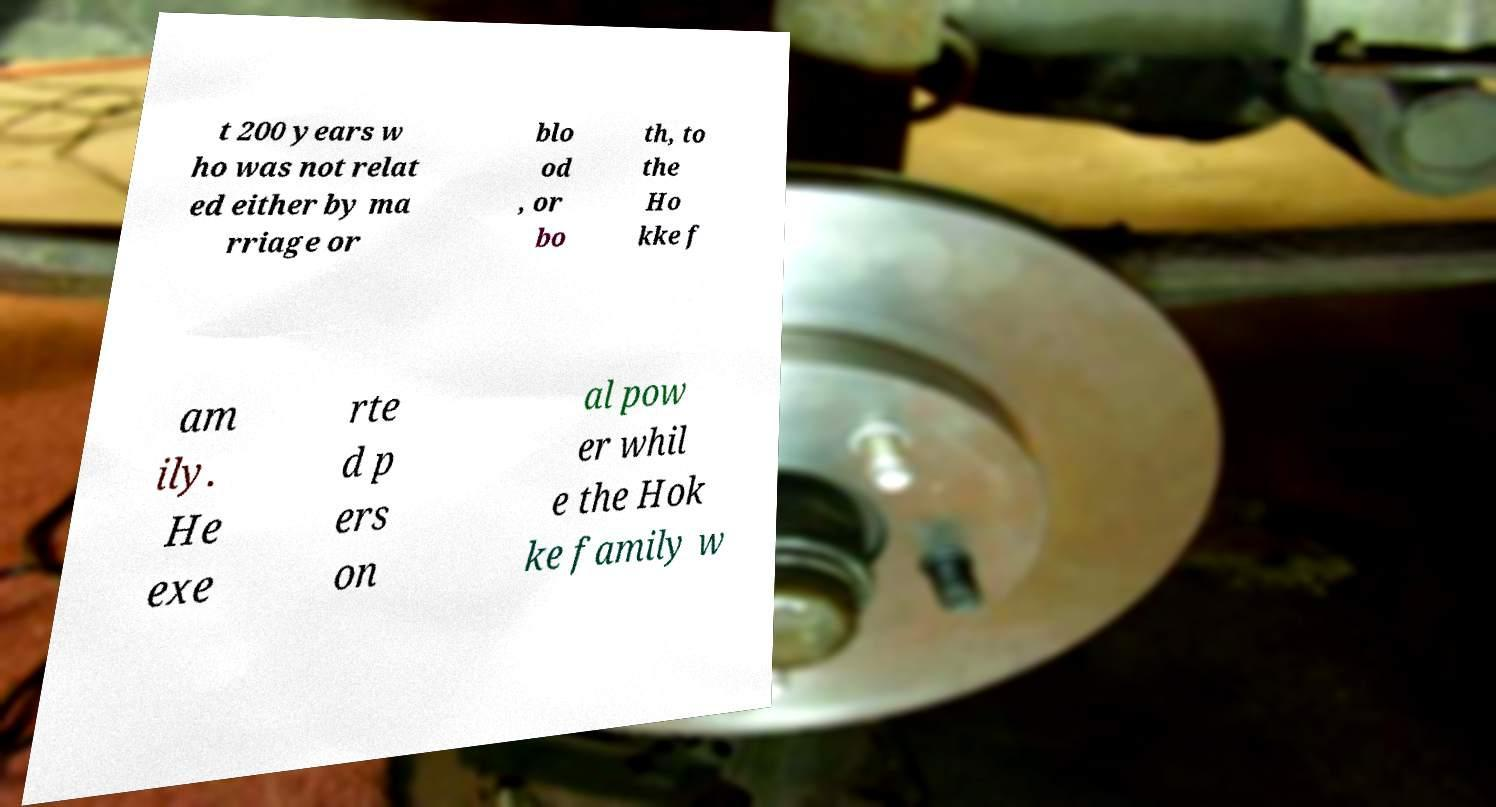Can you read and provide the text displayed in the image?This photo seems to have some interesting text. Can you extract and type it out for me? t 200 years w ho was not relat ed either by ma rriage or blo od , or bo th, to the Ho kke f am ily. He exe rte d p ers on al pow er whil e the Hok ke family w 